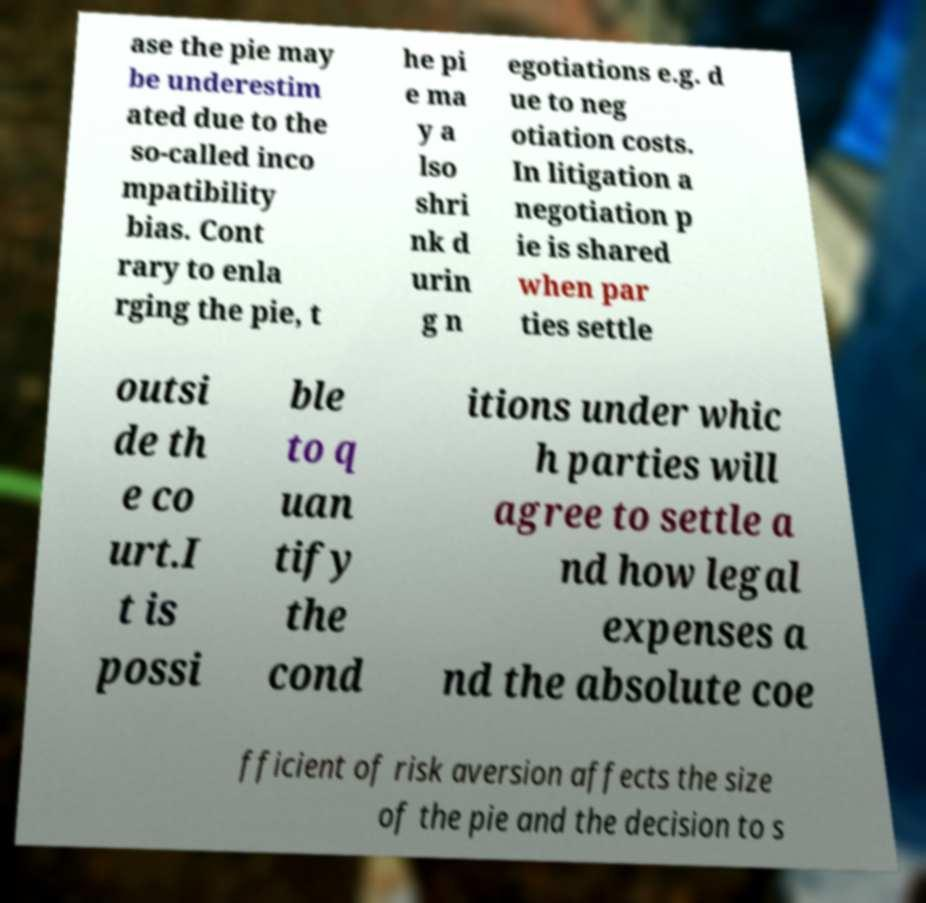Can you read and provide the text displayed in the image?This photo seems to have some interesting text. Can you extract and type it out for me? ase the pie may be underestim ated due to the so-called inco mpatibility bias. Cont rary to enla rging the pie, t he pi e ma y a lso shri nk d urin g n egotiations e.g. d ue to neg otiation costs. In litigation a negotiation p ie is shared when par ties settle outsi de th e co urt.I t is possi ble to q uan tify the cond itions under whic h parties will agree to settle a nd how legal expenses a nd the absolute coe fficient of risk aversion affects the size of the pie and the decision to s 